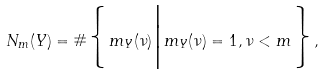Convert formula to latex. <formula><loc_0><loc_0><loc_500><loc_500>N _ { m } ( Y ) = \# \Big \{ m _ { Y } ( \nu ) \Big | m _ { Y } ( \nu ) = 1 , \nu < m \Big \} ,</formula> 